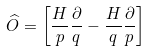Convert formula to latex. <formula><loc_0><loc_0><loc_500><loc_500>\widehat { O } = \left [ \frac { H } { p } \frac { \partial } { q } - \frac { H } { q } \frac { \partial } { p } \right ]</formula> 